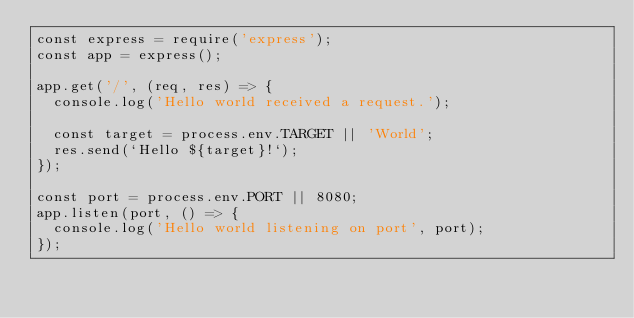<code> <loc_0><loc_0><loc_500><loc_500><_JavaScript_>const express = require('express');
const app = express();

app.get('/', (req, res) => {
  console.log('Hello world received a request.');

  const target = process.env.TARGET || 'World';
  res.send(`Hello ${target}!`);
});

const port = process.env.PORT || 8080;
app.listen(port, () => {
  console.log('Hello world listening on port', port);
});</code> 